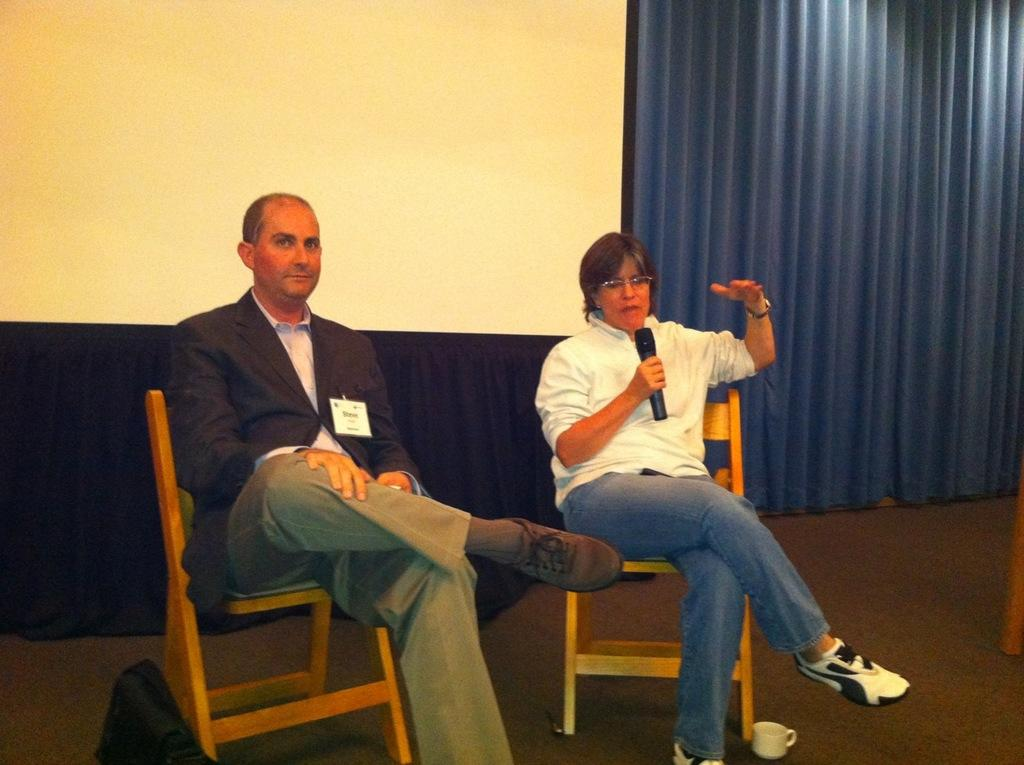How many people are sitting in the image? There are two people sitting on chairs in the image. What object is present that is typically used for amplifying sound? There is a microphone in the image. What type of container is visible in the image? There is a cup in the image. What type of fabric is present in the image? There is a curtain in the image. What type of clock can be seen hanging on the wall in the image? There is no clock visible in the image, nor is there a wall present. 